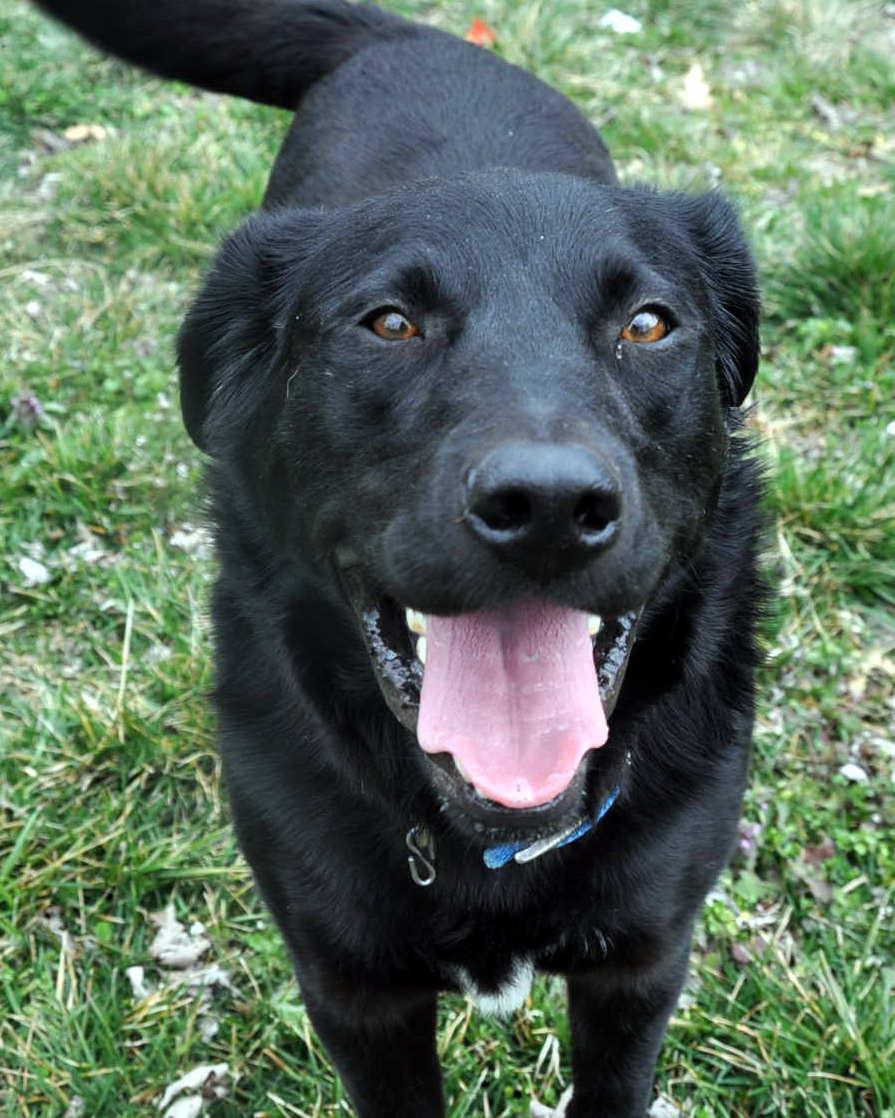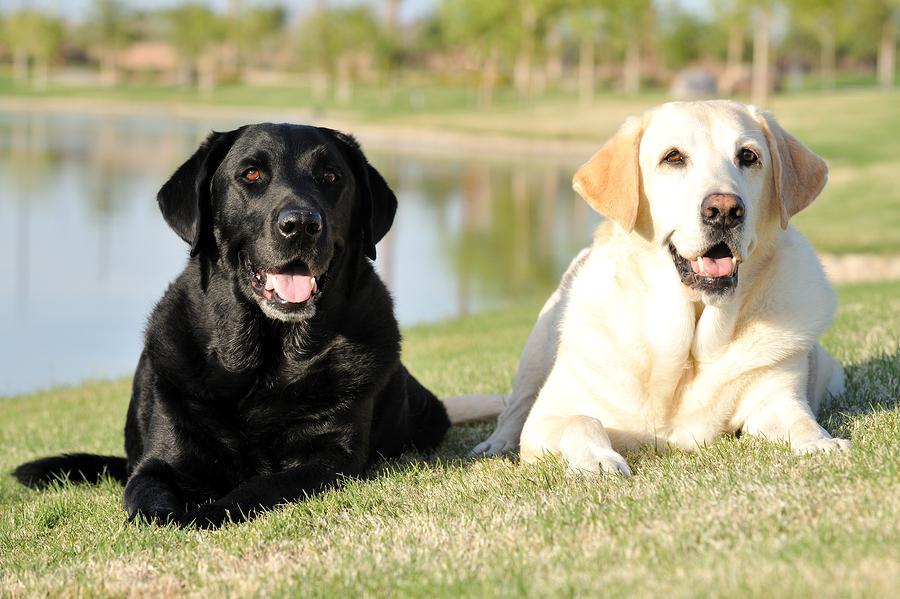The first image is the image on the left, the second image is the image on the right. Examine the images to the left and right. Is the description "The right image contains two dogs that are different colors." accurate? Answer yes or no. Yes. 